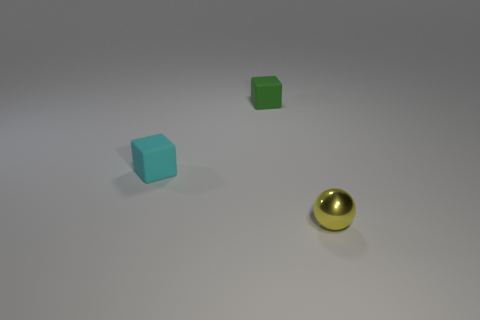Add 2 red cubes. How many objects exist? 5 Subtract 1 spheres. How many spheres are left? 0 Subtract all balls. How many objects are left? 2 Subtract all cyan blocks. How many blocks are left? 1 Subtract all yellow objects. Subtract all green matte objects. How many objects are left? 1 Add 3 cyan blocks. How many cyan blocks are left? 4 Add 1 small cubes. How many small cubes exist? 3 Subtract 1 green blocks. How many objects are left? 2 Subtract all purple cubes. Subtract all green spheres. How many cubes are left? 2 